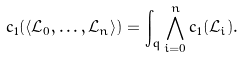<formula> <loc_0><loc_0><loc_500><loc_500>c _ { 1 } ( \langle \mathcal { L } _ { 0 } , \dots , \mathcal { L } _ { n } \rangle ) = \int _ { q } \bigwedge _ { i = 0 } ^ { n } c _ { 1 } ( \mathcal { L } _ { i } ) .</formula> 